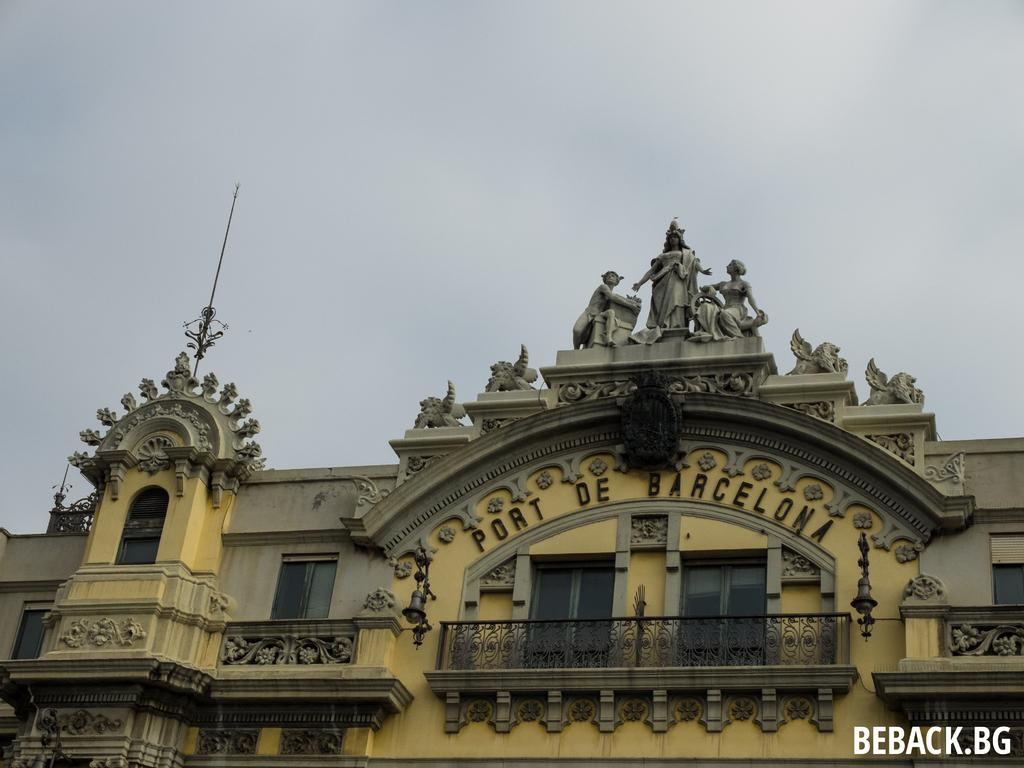<image>
Give a short and clear explanation of the subsequent image. The Port De Barcelona building has ornate detailing on front of the roof. 